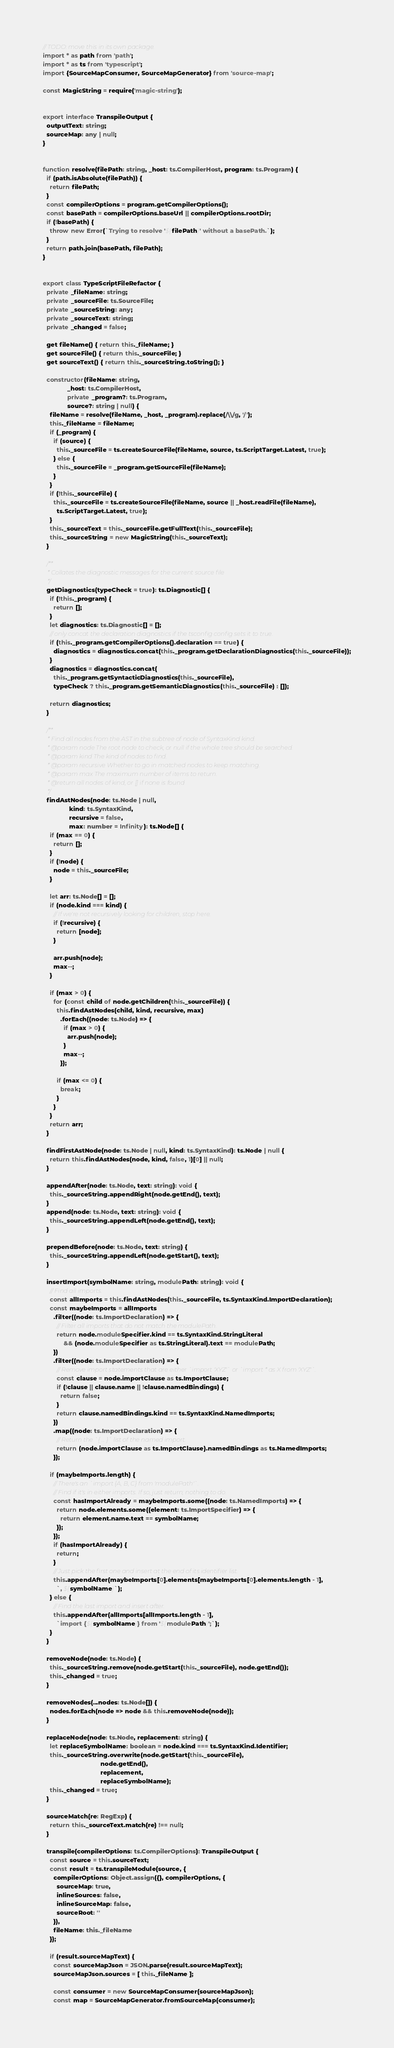Convert code to text. <code><loc_0><loc_0><loc_500><loc_500><_TypeScript_>// TODO: move this in its own package.
import * as path from 'path';
import * as ts from 'typescript';
import {SourceMapConsumer, SourceMapGenerator} from 'source-map';

const MagicString = require('magic-string');


export interface TranspileOutput {
  outputText: string;
  sourceMap: any | null;
}


function resolve(filePath: string, _host: ts.CompilerHost, program: ts.Program) {
  if (path.isAbsolute(filePath)) {
    return filePath;
  }
  const compilerOptions = program.getCompilerOptions();
  const basePath = compilerOptions.baseUrl || compilerOptions.rootDir;
  if (!basePath) {
    throw new Error(`Trying to resolve '${filePath}' without a basePath.`);
  }
  return path.join(basePath, filePath);
}


export class TypeScriptFileRefactor {
  private _fileName: string;
  private _sourceFile: ts.SourceFile;
  private _sourceString: any;
  private _sourceText: string;
  private _changed = false;

  get fileName() { return this._fileName; }
  get sourceFile() { return this._sourceFile; }
  get sourceText() { return this._sourceString.toString(); }

  constructor(fileName: string,
              _host: ts.CompilerHost,
              private _program?: ts.Program,
              source?: string | null) {
    fileName = resolve(fileName, _host, _program).replace(/\\/g, '/');
    this._fileName = fileName;
    if (_program) {
      if (source) {
        this._sourceFile = ts.createSourceFile(fileName, source, ts.ScriptTarget.Latest, true);
      } else {
        this._sourceFile = _program.getSourceFile(fileName);
      }
    }
    if (!this._sourceFile) {
      this._sourceFile = ts.createSourceFile(fileName, source || _host.readFile(fileName),
        ts.ScriptTarget.Latest, true);
    }
    this._sourceText = this._sourceFile.getFullText(this._sourceFile);
    this._sourceString = new MagicString(this._sourceText);
  }

  /**
   * Collates the diagnostic messages for the current source file
   */
  getDiagnostics(typeCheck = true): ts.Diagnostic[] {
    if (!this._program) {
      return [];
    }
    let diagnostics: ts.Diagnostic[] = [];
    // only concat the declaration diagnostics if the tsconfig config sets it to true.
    if (this._program.getCompilerOptions().declaration == true) {
      diagnostics = diagnostics.concat(this._program.getDeclarationDiagnostics(this._sourceFile));
    }
    diagnostics = diagnostics.concat(
      this._program.getSyntacticDiagnostics(this._sourceFile),
      typeCheck ? this._program.getSemanticDiagnostics(this._sourceFile) : []);

    return diagnostics;
  }

  /**
   * Find all nodes from the AST in the subtree of node of SyntaxKind kind.
   * @param node The root node to check, or null if the whole tree should be searched.
   * @param kind The kind of nodes to find.
   * @param recursive Whether to go in matched nodes to keep matching.
   * @param max The maximum number of items to return.
   * @return all nodes of kind, or [] if none is found
   */
  findAstNodes(node: ts.Node | null,
               kind: ts.SyntaxKind,
               recursive = false,
               max: number = Infinity): ts.Node[] {
    if (max == 0) {
      return [];
    }
    if (!node) {
      node = this._sourceFile;
    }

    let arr: ts.Node[] = [];
    if (node.kind === kind) {
      // If we're not recursively looking for children, stop here.
      if (!recursive) {
        return [node];
      }

      arr.push(node);
      max--;
    }

    if (max > 0) {
      for (const child of node.getChildren(this._sourceFile)) {
        this.findAstNodes(child, kind, recursive, max)
          .forEach((node: ts.Node) => {
            if (max > 0) {
              arr.push(node);
            }
            max--;
          });

        if (max <= 0) {
          break;
        }
      }
    }
    return arr;
  }

  findFirstAstNode(node: ts.Node | null, kind: ts.SyntaxKind): ts.Node | null {
    return this.findAstNodes(node, kind, false, 1)[0] || null;
  }

  appendAfter(node: ts.Node, text: string): void {
    this._sourceString.appendRight(node.getEnd(), text);
  }
  append(node: ts.Node, text: string): void {
    this._sourceString.appendLeft(node.getEnd(), text);
  }

  prependBefore(node: ts.Node, text: string) {
    this._sourceString.appendLeft(node.getStart(), text);
  }

  insertImport(symbolName: string, modulePath: string): void {
    // Find all imports.
    const allImports = this.findAstNodes(this._sourceFile, ts.SyntaxKind.ImportDeclaration);
    const maybeImports = allImports
      .filter((node: ts.ImportDeclaration) => {
        // Filter all imports that do not match the modulePath.
        return node.moduleSpecifier.kind == ts.SyntaxKind.StringLiteral
            && (node.moduleSpecifier as ts.StringLiteral).text == modulePath;
      })
      .filter((node: ts.ImportDeclaration) => {
        // Remove import statements that are either `import 'XYZ'` or `import * as X from 'XYZ'`.
        const clause = node.importClause as ts.ImportClause;
        if (!clause || clause.name || !clause.namedBindings) {
          return false;
        }
        return clause.namedBindings.kind == ts.SyntaxKind.NamedImports;
      })
      .map((node: ts.ImportDeclaration) => {
        // Return the `{ ... }` list of the named import.
        return (node.importClause as ts.ImportClause).namedBindings as ts.NamedImports;
      });

    if (maybeImports.length) {
      // There's an `import {A, B, C} from 'modulePath'`.
      // Find if it's in either imports. If so, just return; nothing to do.
      const hasImportAlready = maybeImports.some((node: ts.NamedImports) => {
        return node.elements.some((element: ts.ImportSpecifier) => {
          return element.name.text == symbolName;
        });
      });
      if (hasImportAlready) {
        return;
      }
      // Just pick the first one and insert at the end of its identifier list.
      this.appendAfter(maybeImports[0].elements[maybeImports[0].elements.length - 1],
        `, ${symbolName}`);
    } else {
      // Find the last import and insert after.
      this.appendAfter(allImports[allImports.length - 1],
        `import {${symbolName}} from '${modulePath}';`);
    }
  }

  removeNode(node: ts.Node) {
    this._sourceString.remove(node.getStart(this._sourceFile), node.getEnd());
    this._changed = true;
  }

  removeNodes(...nodes: ts.Node[]) {
    nodes.forEach(node => node && this.removeNode(node));
  }

  replaceNode(node: ts.Node, replacement: string) {
    let replaceSymbolName: boolean = node.kind === ts.SyntaxKind.Identifier;
    this._sourceString.overwrite(node.getStart(this._sourceFile),
                                 node.getEnd(),
                                 replacement,
                                 replaceSymbolName);
    this._changed = true;
  }

  sourceMatch(re: RegExp) {
    return this._sourceText.match(re) !== null;
  }

  transpile(compilerOptions: ts.CompilerOptions): TranspileOutput {
    const source = this.sourceText;
    const result = ts.transpileModule(source, {
      compilerOptions: Object.assign({}, compilerOptions, {
        sourceMap: true,
        inlineSources: false,
        inlineSourceMap: false,
        sourceRoot: ''
      }),
      fileName: this._fileName
    });

    if (result.sourceMapText) {
      const sourceMapJson = JSON.parse(result.sourceMapText);
      sourceMapJson.sources = [ this._fileName ];

      const consumer = new SourceMapConsumer(sourceMapJson);
      const map = SourceMapGenerator.fromSourceMap(consumer);</code> 